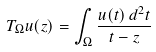Convert formula to latex. <formula><loc_0><loc_0><loc_500><loc_500>T _ { \Omega } u ( z ) = \int _ { \Omega } \frac { u ( t ) \, d ^ { 2 } t } { t - z }</formula> 